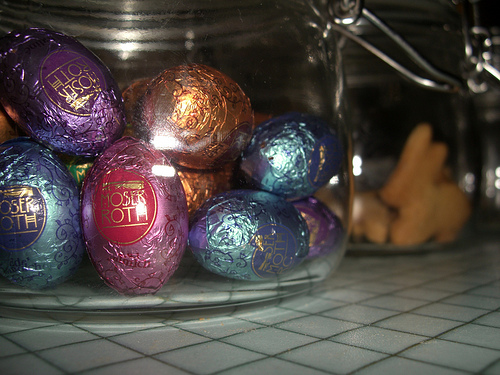<image>
Is there a eggs on the table? Yes. Looking at the image, I can see the eggs is positioned on top of the table, with the table providing support. Where is the chocolate in relation to the countertop? Is it on the countertop? No. The chocolate is not positioned on the countertop. They may be near each other, but the chocolate is not supported by or resting on top of the countertop. Is there a snack next to the plate? No. The snack is not positioned next to the plate. They are located in different areas of the scene. 